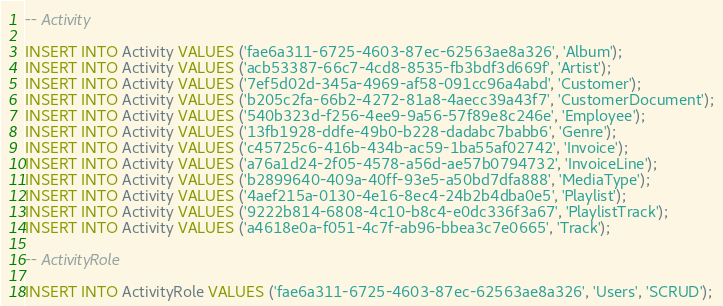<code> <loc_0><loc_0><loc_500><loc_500><_SQL_>
-- Activity

INSERT INTO Activity VALUES ('fae6a311-6725-4603-87ec-62563ae8a326', 'Album');
INSERT INTO Activity VALUES ('acb53387-66c7-4cd8-8535-fb3bdf3d669f', 'Artist');
INSERT INTO Activity VALUES ('7ef5d02d-345a-4969-af58-091cc96a4abd', 'Customer');
INSERT INTO Activity VALUES ('b205c2fa-66b2-4272-81a8-4aecc39a43f7', 'CustomerDocument');
INSERT INTO Activity VALUES ('540b323d-f256-4ee9-9a56-57f89e8c246e', 'Employee');
INSERT INTO Activity VALUES ('13fb1928-ddfe-49b0-b228-dadabc7babb6', 'Genre');
INSERT INTO Activity VALUES ('c45725c6-416b-434b-ac59-1ba55af02742', 'Invoice');
INSERT INTO Activity VALUES ('a76a1d24-2f05-4578-a56d-ae57b0794732', 'InvoiceLine');
INSERT INTO Activity VALUES ('b2899640-409a-40ff-93e5-a50bd7dfa888', 'MediaType');
INSERT INTO Activity VALUES ('4aef215a-0130-4e16-8ec4-24b2b4dba0e5', 'Playlist');
INSERT INTO Activity VALUES ('9222b814-6808-4c10-b8c4-e0dc336f3a67', 'PlaylistTrack');
INSERT INTO Activity VALUES ('a4618e0a-f051-4c7f-ab96-bbea3c7e0665', 'Track');

-- ActivityRole

INSERT INTO ActivityRole VALUES ('fae6a311-6725-4603-87ec-62563ae8a326', 'Users', 'SCRUD');</code> 